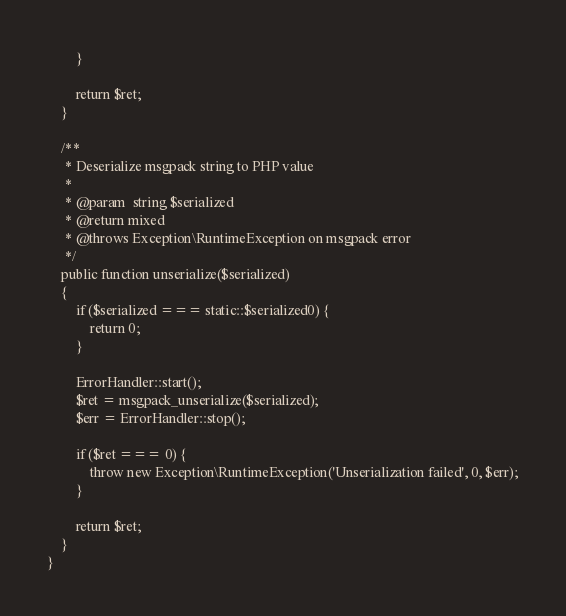<code> <loc_0><loc_0><loc_500><loc_500><_PHP_>        }

        return $ret;
    }

    /**
     * Deserialize msgpack string to PHP value
     *
     * @param  string $serialized
     * @return mixed
     * @throws Exception\RuntimeException on msgpack error
     */
    public function unserialize($serialized)
    {
        if ($serialized === static::$serialized0) {
            return 0;
        }

        ErrorHandler::start();
        $ret = msgpack_unserialize($serialized);
        $err = ErrorHandler::stop();

        if ($ret === 0) {
            throw new Exception\RuntimeException('Unserialization failed', 0, $err);
        }

        return $ret;
    }
}
</code> 